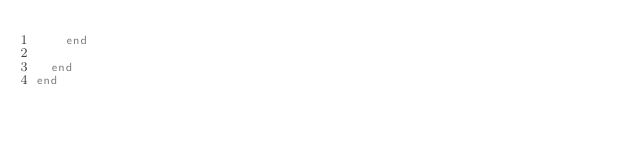Convert code to text. <code><loc_0><loc_0><loc_500><loc_500><_Ruby_>    end

  end
end</code> 